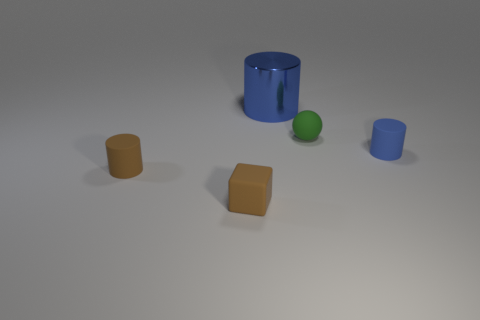There is a tiny blue thing; what shape is it?
Provide a short and direct response. Cylinder. How many rubber things have the same color as the tiny rubber cube?
Keep it short and to the point. 1. There is a matte cylinder in front of the tiny cylinder that is to the right of the brown matte thing to the right of the brown cylinder; what size is it?
Your answer should be compact. Small. What is the size of the brown thing that is the same shape as the small blue thing?
Your response must be concise. Small. How many tiny things are cylinders or blue cubes?
Your answer should be compact. 2. Is the material of the thing in front of the brown cylinder the same as the small cylinder that is left of the metallic thing?
Keep it short and to the point. Yes. There is a cylinder on the right side of the blue metal object; what is its material?
Ensure brevity in your answer.  Rubber. What number of matte things are blue things or tiny blue things?
Provide a short and direct response. 1. The tiny cylinder that is on the right side of the green rubber object right of the big metal cylinder is what color?
Ensure brevity in your answer.  Blue. Does the green ball have the same material as the blue cylinder that is behind the tiny green matte ball?
Provide a short and direct response. No. 